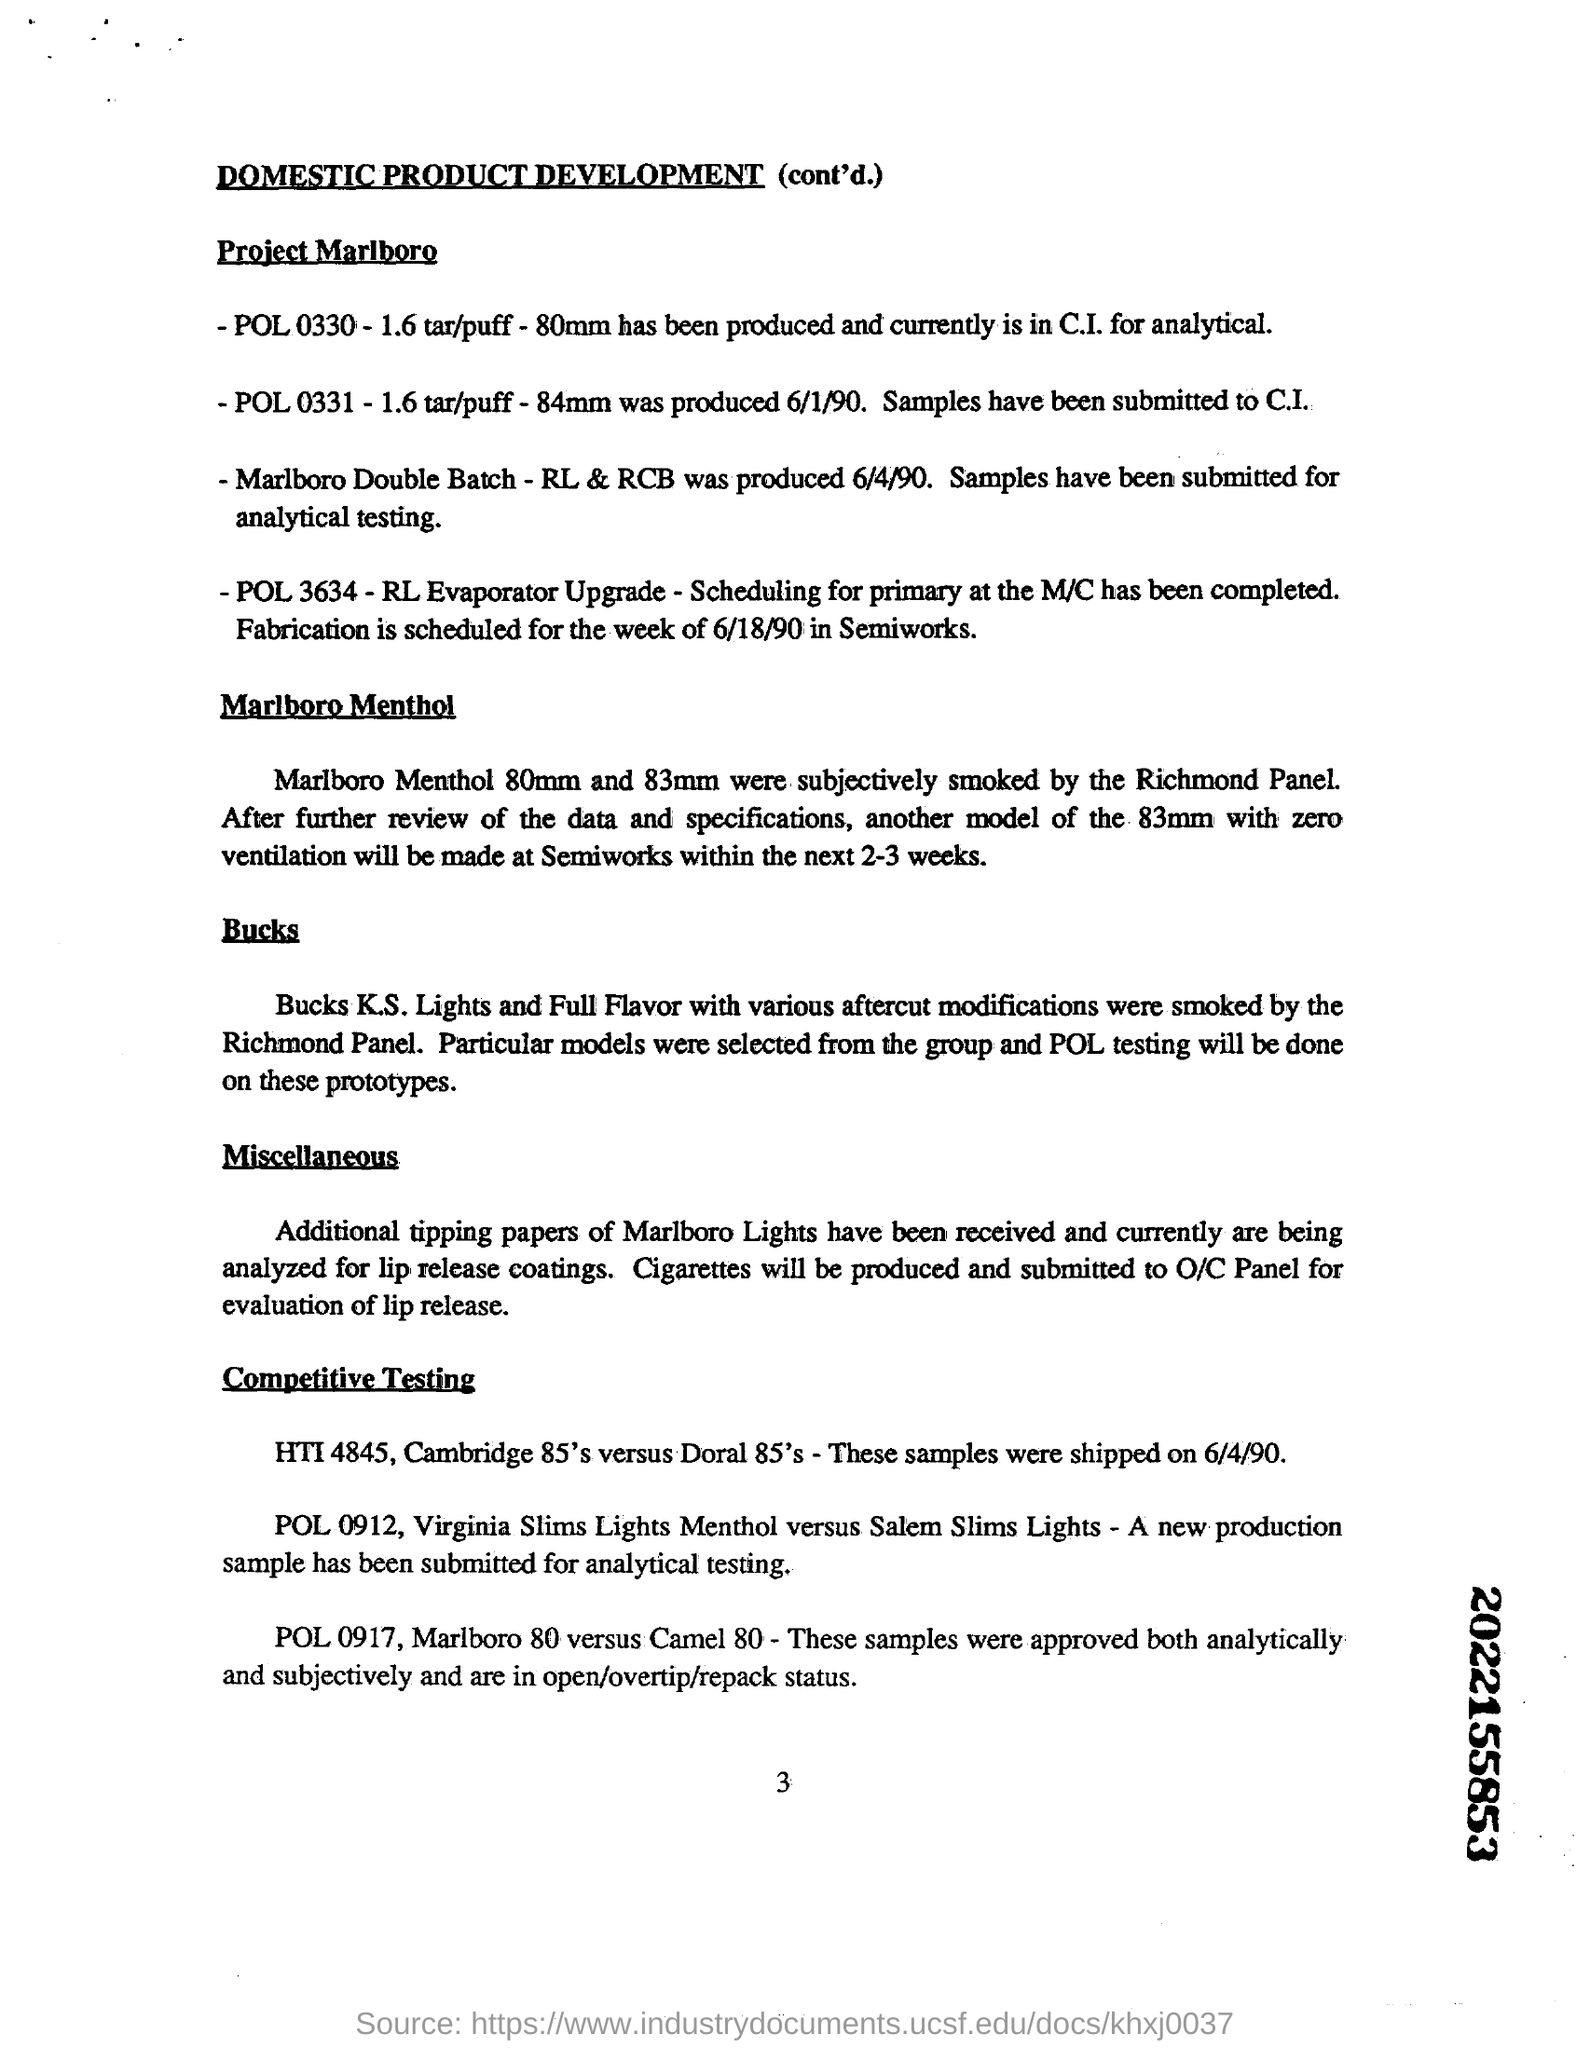Can you describe the modifications made to the 83mm Marlboro Menthol cigarettes as mentioned in the document? The document mentions that another model of the 83mm Marlboro Menthol cigarettes will receive changes to its ventilation. This likely refers to modifying the filter design to alter the airflow and potentially adjust the intensity and flavor experience of the smoke. 